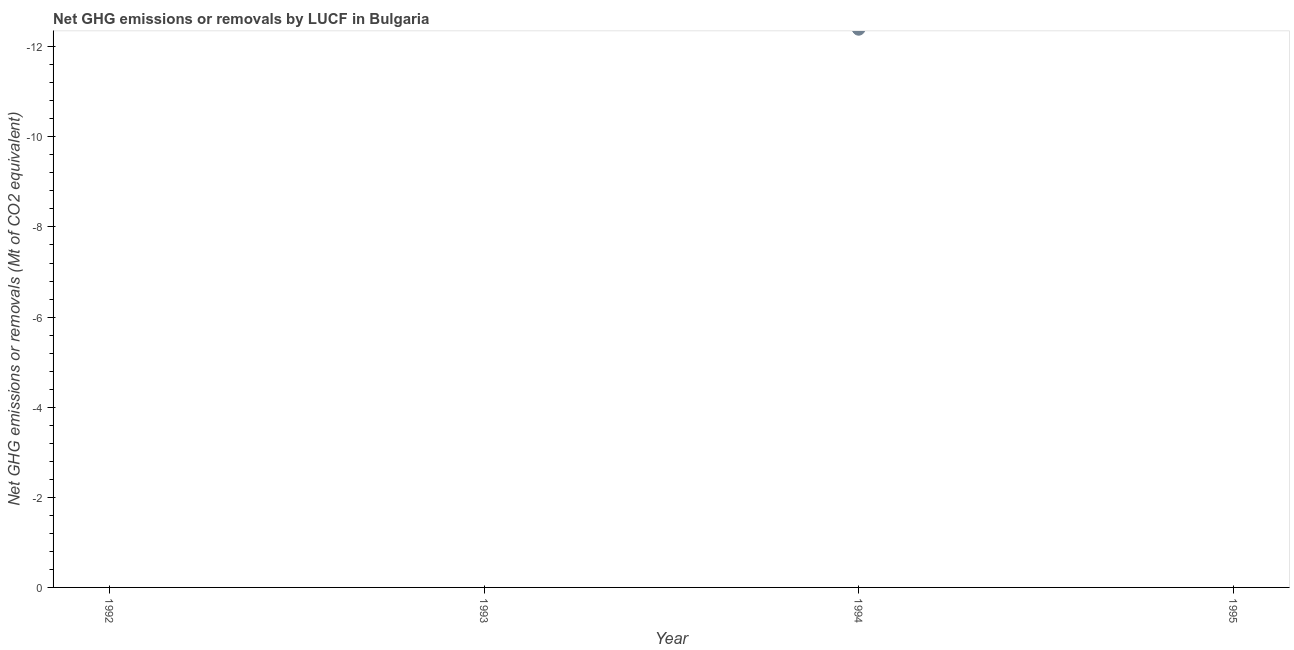What is the ghg net emissions or removals in 1994?
Keep it short and to the point. 0. What is the average ghg net emissions or removals per year?
Give a very brief answer. 0. In how many years, is the ghg net emissions or removals greater than the average ghg net emissions or removals taken over all years?
Offer a terse response. 0. Does the ghg net emissions or removals monotonically increase over the years?
Offer a very short reply. No. How many years are there in the graph?
Give a very brief answer. 4. Are the values on the major ticks of Y-axis written in scientific E-notation?
Offer a terse response. No. Does the graph contain any zero values?
Ensure brevity in your answer.  Yes. Does the graph contain grids?
Offer a very short reply. No. What is the title of the graph?
Your answer should be very brief. Net GHG emissions or removals by LUCF in Bulgaria. What is the label or title of the X-axis?
Provide a short and direct response. Year. What is the label or title of the Y-axis?
Give a very brief answer. Net GHG emissions or removals (Mt of CO2 equivalent). What is the Net GHG emissions or removals (Mt of CO2 equivalent) in 1993?
Offer a terse response. 0. What is the Net GHG emissions or removals (Mt of CO2 equivalent) in 1995?
Make the answer very short. 0. 